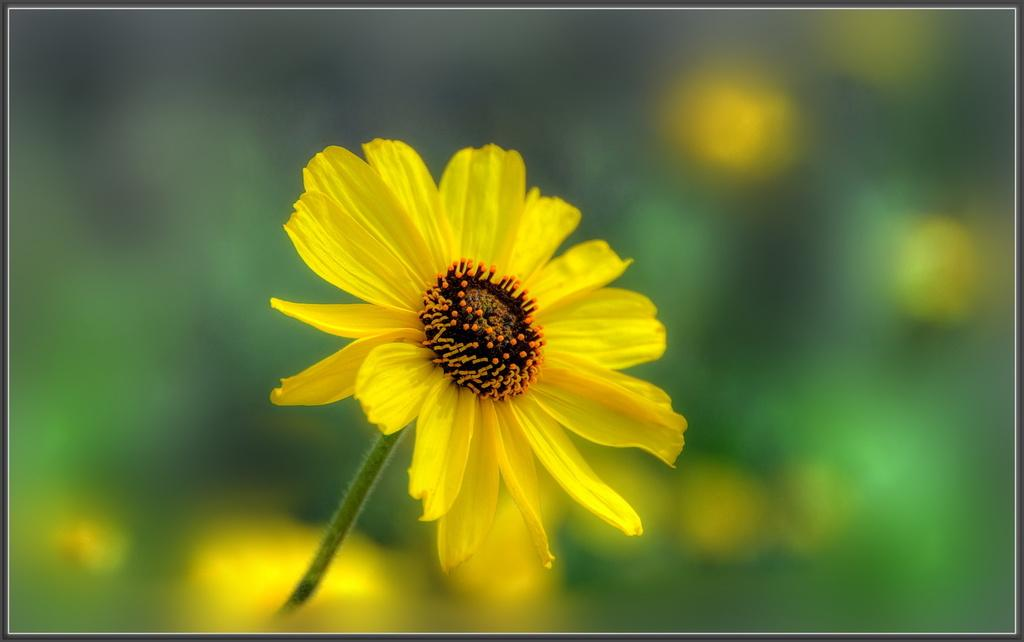What type of plant is in the image? There is a sunflower in the image. Can you describe the background of the image? The background of the image is blurred. What type of wave can be seen crashing on the street in the image? There is no wave or street present in the image; it features a sunflower with a blurred background. 